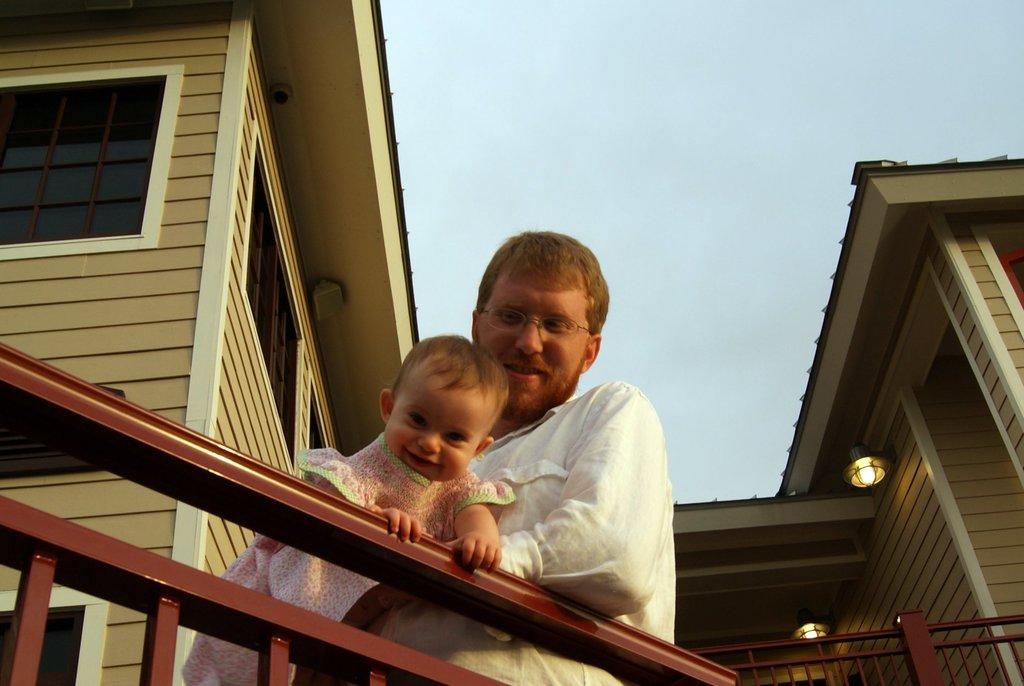How would you summarize this image in a sentence or two? In this image we can see a man holding a baby. There is a building, lights and railing. In the background there is sky.  